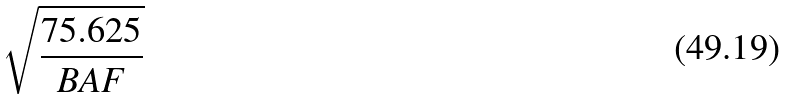Convert formula to latex. <formula><loc_0><loc_0><loc_500><loc_500>\sqrt { \frac { 7 5 . 6 2 5 } { B A F } }</formula> 